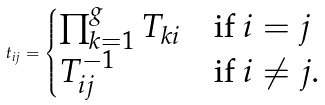Convert formula to latex. <formula><loc_0><loc_0><loc_500><loc_500>t _ { i j } = \begin{cases} \prod _ { k = 1 } ^ { g } T _ { k i } & \text {if $i=j$} \\ T _ { i j } ^ { - 1 } & \text {if $i\neq j$.} \end{cases}</formula> 